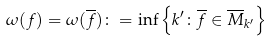Convert formula to latex. <formula><loc_0><loc_0><loc_500><loc_500>\omega ( f ) = \omega ( \overline { f } ) \colon = \inf \left \{ k ^ { \prime } \colon \overline { f } \in \overline { M } _ { k ^ { \prime } } \right \}</formula> 